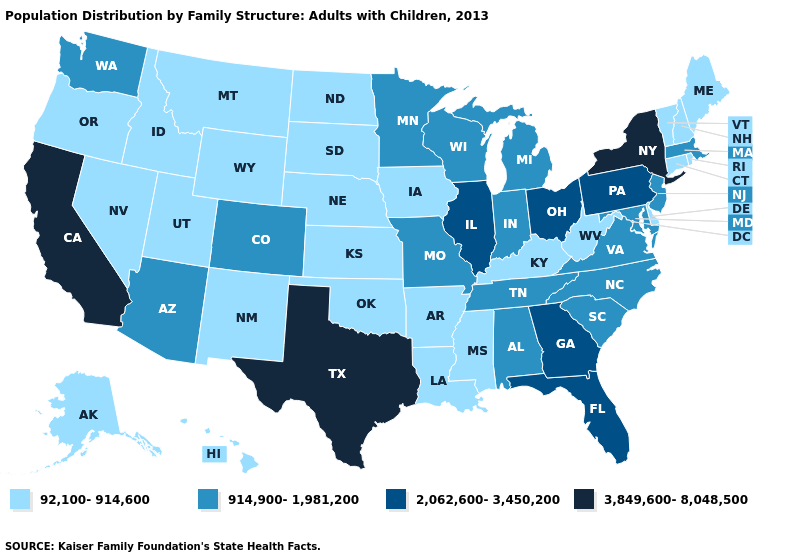Does Rhode Island have a higher value than California?
Be succinct. No. Is the legend a continuous bar?
Quick response, please. No. Is the legend a continuous bar?
Answer briefly. No. What is the lowest value in states that border Rhode Island?
Quick response, please. 92,100-914,600. Which states have the lowest value in the MidWest?
Quick response, please. Iowa, Kansas, Nebraska, North Dakota, South Dakota. Among the states that border Maryland , does West Virginia have the lowest value?
Short answer required. Yes. Does Maine have a lower value than North Carolina?
Keep it brief. Yes. What is the highest value in the Northeast ?
Write a very short answer. 3,849,600-8,048,500. Name the states that have a value in the range 3,849,600-8,048,500?
Quick response, please. California, New York, Texas. What is the value of Colorado?
Give a very brief answer. 914,900-1,981,200. Name the states that have a value in the range 3,849,600-8,048,500?
Write a very short answer. California, New York, Texas. What is the value of Utah?
Short answer required. 92,100-914,600. What is the lowest value in the USA?
Keep it brief. 92,100-914,600. What is the lowest value in states that border Wisconsin?
Concise answer only. 92,100-914,600. 